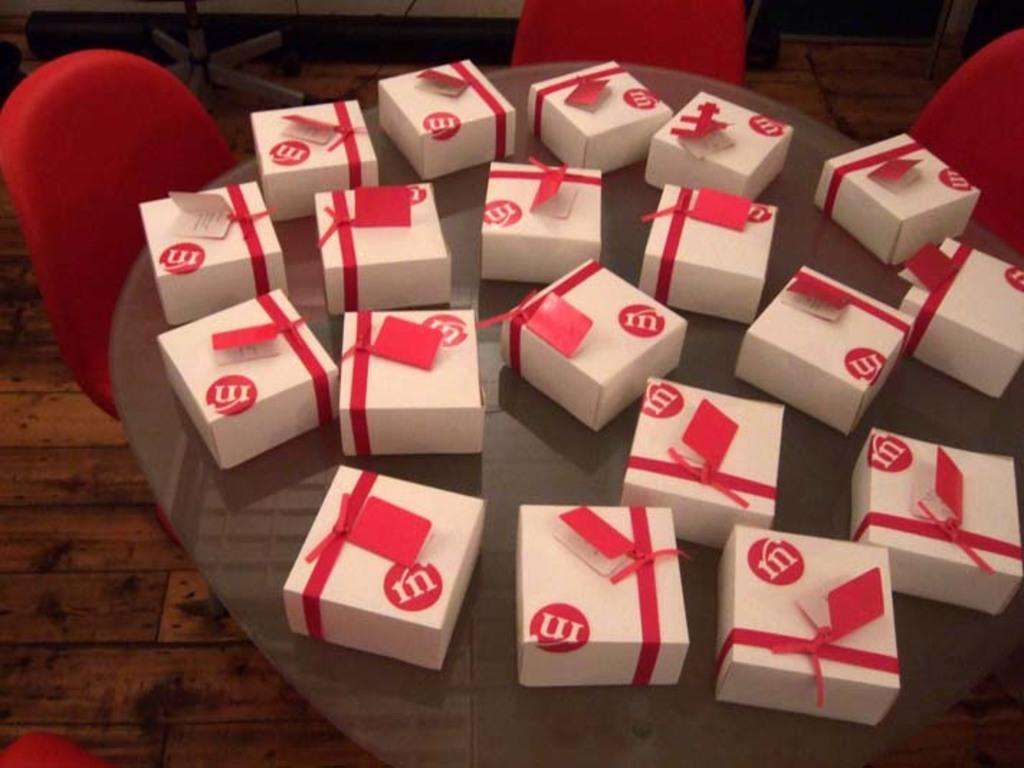<image>
Render a clear and concise summary of the photo. a bunch of white gifts with the word M on red. 